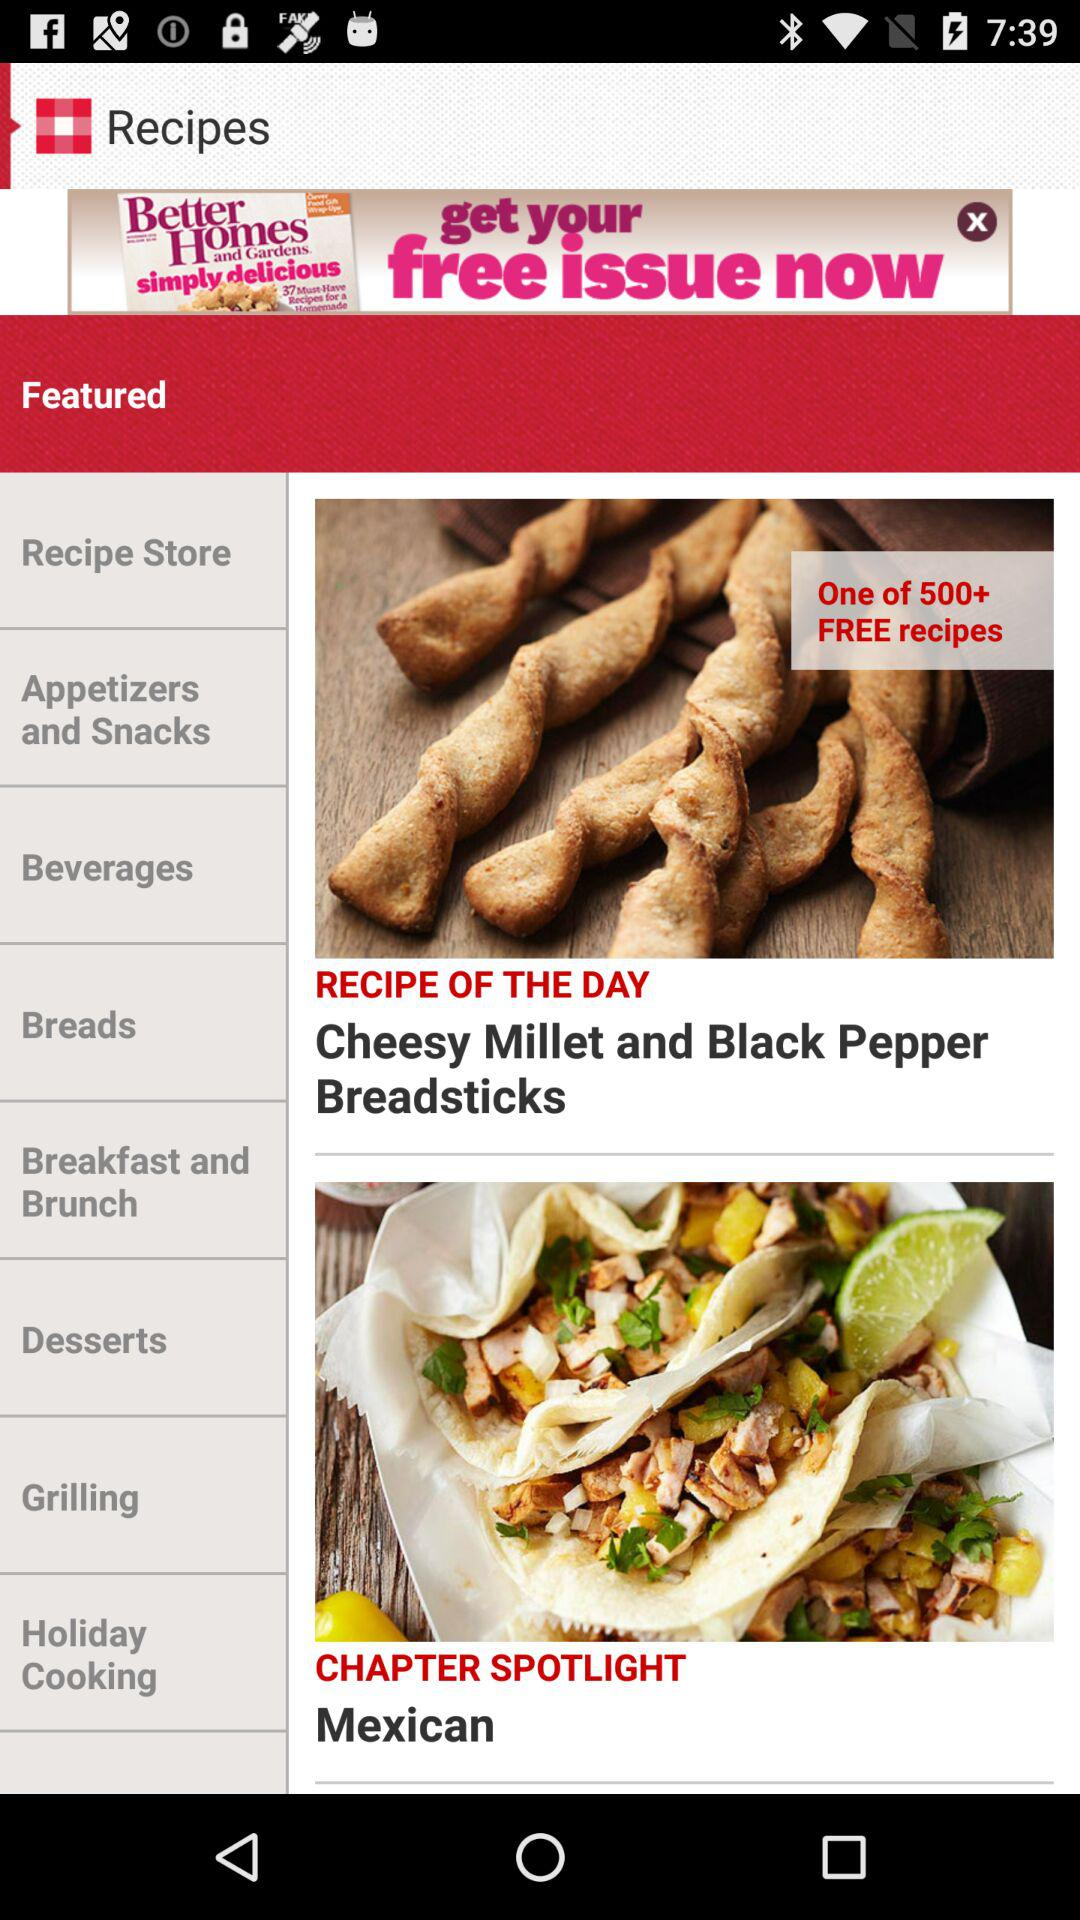What is the recipe of the day? The recipe of the day is "Cheesy Millet and Black Pepper Breadsticks". 